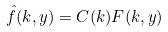<formula> <loc_0><loc_0><loc_500><loc_500>\hat { f } ( k , y ) = C ( k ) F ( k , y )</formula> 